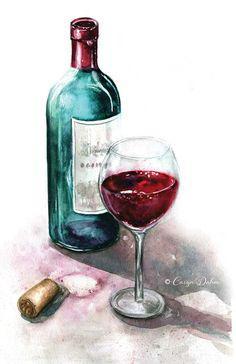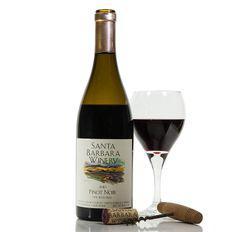The first image is the image on the left, the second image is the image on the right. For the images shown, is this caption "There is exactly one wineglass sitting on the left side of the bottle in the image on the left." true? Answer yes or no. No. The first image is the image on the left, the second image is the image on the right. Evaluate the accuracy of this statement regarding the images: "One of the bottles of wine is green and sits near a pile of grapes.". Is it true? Answer yes or no. No. 